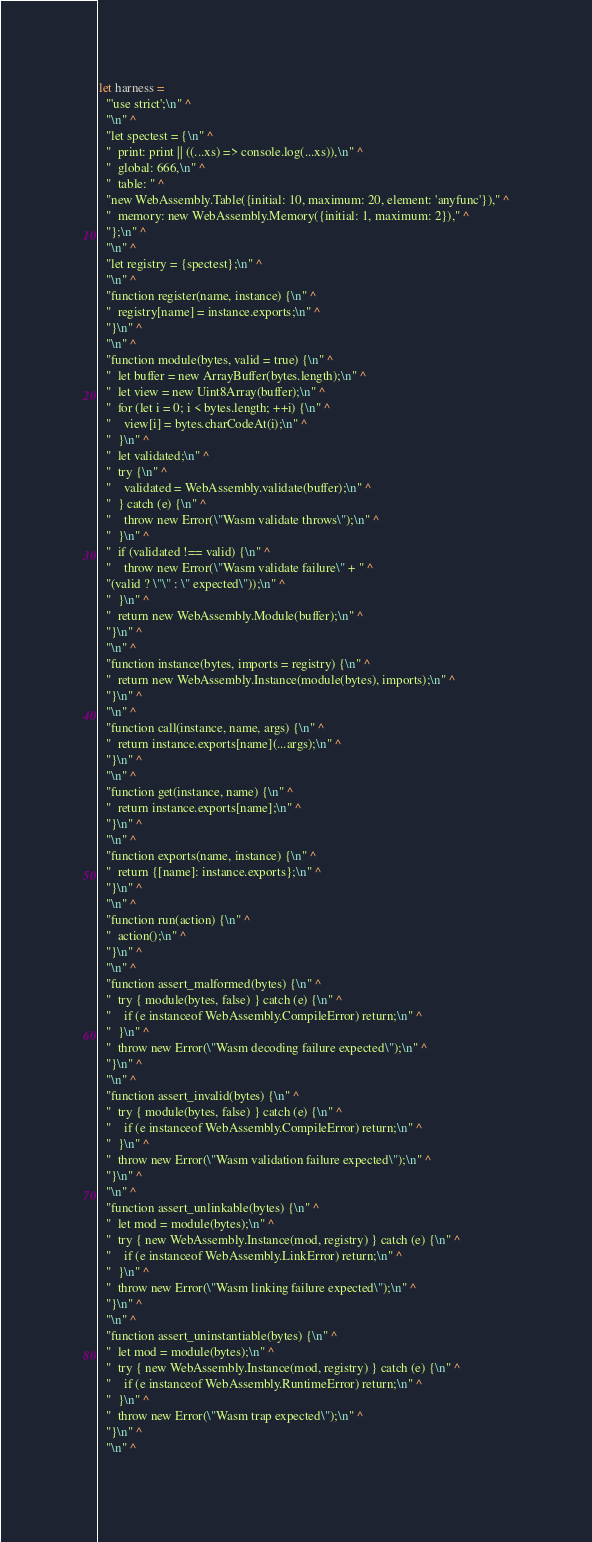Convert code to text. <code><loc_0><loc_0><loc_500><loc_500><_OCaml_>
let harness =
  "'use strict';\n" ^
  "\n" ^
  "let spectest = {\n" ^
  "  print: print || ((...xs) => console.log(...xs)),\n" ^
  "  global: 666,\n" ^
  "  table: " ^
  "new WebAssembly.Table({initial: 10, maximum: 20, element: 'anyfunc'})," ^
  "  memory: new WebAssembly.Memory({initial: 1, maximum: 2})," ^
  "};\n" ^
  "\n" ^
  "let registry = {spectest};\n" ^
  "\n" ^
  "function register(name, instance) {\n" ^
  "  registry[name] = instance.exports;\n" ^
  "}\n" ^
  "\n" ^
  "function module(bytes, valid = true) {\n" ^
  "  let buffer = new ArrayBuffer(bytes.length);\n" ^
  "  let view = new Uint8Array(buffer);\n" ^
  "  for (let i = 0; i < bytes.length; ++i) {\n" ^
  "    view[i] = bytes.charCodeAt(i);\n" ^
  "  }\n" ^
  "  let validated;\n" ^
  "  try {\n" ^
  "    validated = WebAssembly.validate(buffer);\n" ^
  "  } catch (e) {\n" ^
  "    throw new Error(\"Wasm validate throws\");\n" ^
  "  }\n" ^
  "  if (validated !== valid) {\n" ^
  "    throw new Error(\"Wasm validate failure\" + " ^
  "(valid ? \"\" : \" expected\"));\n" ^
  "  }\n" ^
  "  return new WebAssembly.Module(buffer);\n" ^
  "}\n" ^
  "\n" ^
  "function instance(bytes, imports = registry) {\n" ^
  "  return new WebAssembly.Instance(module(bytes), imports);\n" ^
  "}\n" ^
  "\n" ^
  "function call(instance, name, args) {\n" ^
  "  return instance.exports[name](...args);\n" ^
  "}\n" ^
  "\n" ^
  "function get(instance, name) {\n" ^
  "  return instance.exports[name];\n" ^
  "}\n" ^
  "\n" ^
  "function exports(name, instance) {\n" ^
  "  return {[name]: instance.exports};\n" ^
  "}\n" ^
  "\n" ^
  "function run(action) {\n" ^
  "  action();\n" ^
  "}\n" ^
  "\n" ^
  "function assert_malformed(bytes) {\n" ^
  "  try { module(bytes, false) } catch (e) {\n" ^
  "    if (e instanceof WebAssembly.CompileError) return;\n" ^
  "  }\n" ^
  "  throw new Error(\"Wasm decoding failure expected\");\n" ^
  "}\n" ^
  "\n" ^
  "function assert_invalid(bytes) {\n" ^
  "  try { module(bytes, false) } catch (e) {\n" ^
  "    if (e instanceof WebAssembly.CompileError) return;\n" ^
  "  }\n" ^
  "  throw new Error(\"Wasm validation failure expected\");\n" ^
  "}\n" ^
  "\n" ^
  "function assert_unlinkable(bytes) {\n" ^
  "  let mod = module(bytes);\n" ^
  "  try { new WebAssembly.Instance(mod, registry) } catch (e) {\n" ^
  "    if (e instanceof WebAssembly.LinkError) return;\n" ^
  "  }\n" ^
  "  throw new Error(\"Wasm linking failure expected\");\n" ^
  "}\n" ^
  "\n" ^
  "function assert_uninstantiable(bytes) {\n" ^
  "  let mod = module(bytes);\n" ^
  "  try { new WebAssembly.Instance(mod, registry) } catch (e) {\n" ^
  "    if (e instanceof WebAssembly.RuntimeError) return;\n" ^
  "  }\n" ^
  "  throw new Error(\"Wasm trap expected\");\n" ^
  "}\n" ^
  "\n" ^</code> 